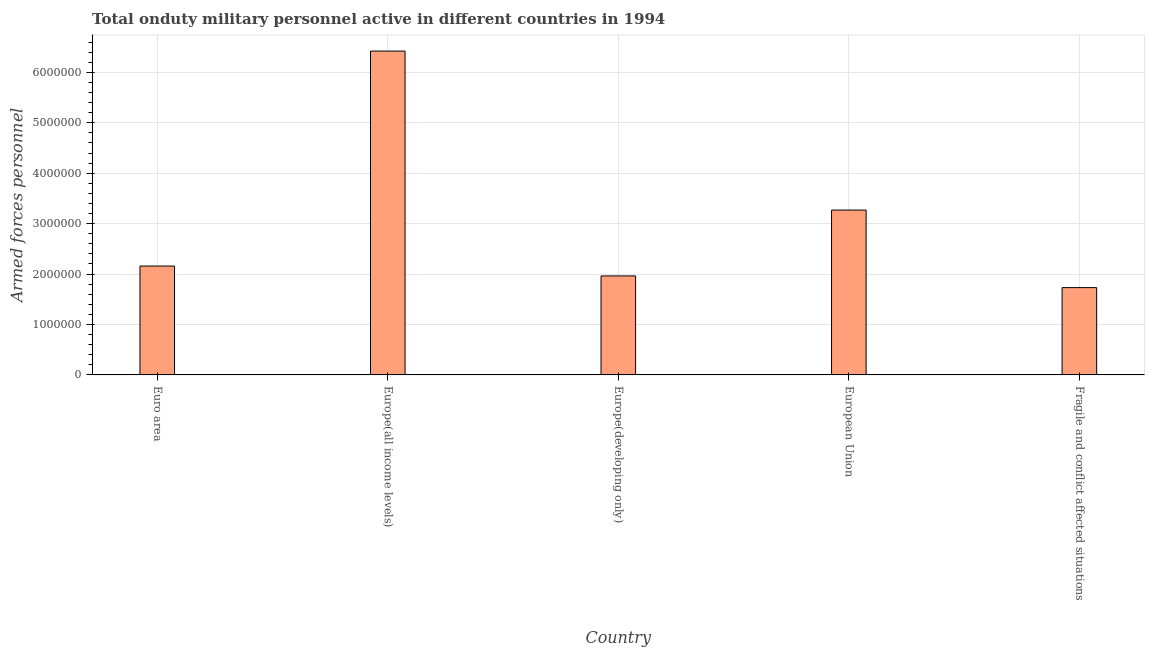Does the graph contain grids?
Provide a succinct answer. Yes. What is the title of the graph?
Offer a terse response. Total onduty military personnel active in different countries in 1994. What is the label or title of the Y-axis?
Give a very brief answer. Armed forces personnel. What is the number of armed forces personnel in Europe(all income levels)?
Your answer should be very brief. 6.42e+06. Across all countries, what is the maximum number of armed forces personnel?
Give a very brief answer. 6.42e+06. Across all countries, what is the minimum number of armed forces personnel?
Make the answer very short. 1.73e+06. In which country was the number of armed forces personnel maximum?
Offer a very short reply. Europe(all income levels). In which country was the number of armed forces personnel minimum?
Your answer should be very brief. Fragile and conflict affected situations. What is the sum of the number of armed forces personnel?
Provide a short and direct response. 1.55e+07. What is the difference between the number of armed forces personnel in Euro area and Europe(developing only)?
Provide a succinct answer. 1.96e+05. What is the average number of armed forces personnel per country?
Your answer should be compact. 3.11e+06. What is the median number of armed forces personnel?
Provide a short and direct response. 2.16e+06. What is the ratio of the number of armed forces personnel in Euro area to that in Fragile and conflict affected situations?
Make the answer very short. 1.25. What is the difference between the highest and the second highest number of armed forces personnel?
Give a very brief answer. 3.15e+06. Is the sum of the number of armed forces personnel in Euro area and Europe(all income levels) greater than the maximum number of armed forces personnel across all countries?
Give a very brief answer. Yes. What is the difference between the highest and the lowest number of armed forces personnel?
Your response must be concise. 4.69e+06. How many countries are there in the graph?
Your answer should be very brief. 5. What is the difference between two consecutive major ticks on the Y-axis?
Keep it short and to the point. 1.00e+06. What is the Armed forces personnel of Euro area?
Your answer should be very brief. 2.16e+06. What is the Armed forces personnel in Europe(all income levels)?
Give a very brief answer. 6.42e+06. What is the Armed forces personnel in Europe(developing only)?
Your response must be concise. 1.96e+06. What is the Armed forces personnel of European Union?
Ensure brevity in your answer.  3.27e+06. What is the Armed forces personnel of Fragile and conflict affected situations?
Your answer should be compact. 1.73e+06. What is the difference between the Armed forces personnel in Euro area and Europe(all income levels)?
Keep it short and to the point. -4.26e+06. What is the difference between the Armed forces personnel in Euro area and Europe(developing only)?
Ensure brevity in your answer.  1.96e+05. What is the difference between the Armed forces personnel in Euro area and European Union?
Ensure brevity in your answer.  -1.11e+06. What is the difference between the Armed forces personnel in Euro area and Fragile and conflict affected situations?
Make the answer very short. 4.28e+05. What is the difference between the Armed forces personnel in Europe(all income levels) and Europe(developing only)?
Offer a very short reply. 4.46e+06. What is the difference between the Armed forces personnel in Europe(all income levels) and European Union?
Offer a very short reply. 3.15e+06. What is the difference between the Armed forces personnel in Europe(all income levels) and Fragile and conflict affected situations?
Your answer should be compact. 4.69e+06. What is the difference between the Armed forces personnel in Europe(developing only) and European Union?
Provide a short and direct response. -1.31e+06. What is the difference between the Armed forces personnel in Europe(developing only) and Fragile and conflict affected situations?
Provide a short and direct response. 2.32e+05. What is the difference between the Armed forces personnel in European Union and Fragile and conflict affected situations?
Ensure brevity in your answer.  1.54e+06. What is the ratio of the Armed forces personnel in Euro area to that in Europe(all income levels)?
Offer a terse response. 0.34. What is the ratio of the Armed forces personnel in Euro area to that in European Union?
Keep it short and to the point. 0.66. What is the ratio of the Armed forces personnel in Euro area to that in Fragile and conflict affected situations?
Provide a short and direct response. 1.25. What is the ratio of the Armed forces personnel in Europe(all income levels) to that in Europe(developing only)?
Offer a terse response. 3.27. What is the ratio of the Armed forces personnel in Europe(all income levels) to that in European Union?
Offer a terse response. 1.97. What is the ratio of the Armed forces personnel in Europe(all income levels) to that in Fragile and conflict affected situations?
Provide a succinct answer. 3.71. What is the ratio of the Armed forces personnel in Europe(developing only) to that in European Union?
Offer a terse response. 0.6. What is the ratio of the Armed forces personnel in Europe(developing only) to that in Fragile and conflict affected situations?
Ensure brevity in your answer.  1.13. What is the ratio of the Armed forces personnel in European Union to that in Fragile and conflict affected situations?
Give a very brief answer. 1.89. 